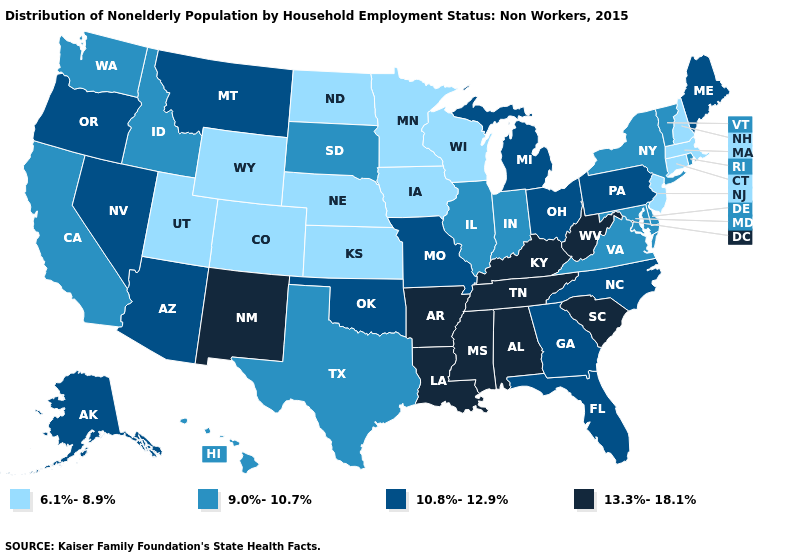Which states have the lowest value in the USA?
Give a very brief answer. Colorado, Connecticut, Iowa, Kansas, Massachusetts, Minnesota, Nebraska, New Hampshire, New Jersey, North Dakota, Utah, Wisconsin, Wyoming. Name the states that have a value in the range 6.1%-8.9%?
Answer briefly. Colorado, Connecticut, Iowa, Kansas, Massachusetts, Minnesota, Nebraska, New Hampshire, New Jersey, North Dakota, Utah, Wisconsin, Wyoming. Does Massachusetts have the same value as Wisconsin?
Concise answer only. Yes. Name the states that have a value in the range 6.1%-8.9%?
Answer briefly. Colorado, Connecticut, Iowa, Kansas, Massachusetts, Minnesota, Nebraska, New Hampshire, New Jersey, North Dakota, Utah, Wisconsin, Wyoming. Which states hav the highest value in the MidWest?
Be succinct. Michigan, Missouri, Ohio. Which states have the lowest value in the MidWest?
Write a very short answer. Iowa, Kansas, Minnesota, Nebraska, North Dakota, Wisconsin. Does South Dakota have a lower value than Alaska?
Short answer required. Yes. Name the states that have a value in the range 6.1%-8.9%?
Be succinct. Colorado, Connecticut, Iowa, Kansas, Massachusetts, Minnesota, Nebraska, New Hampshire, New Jersey, North Dakota, Utah, Wisconsin, Wyoming. Does Florida have a higher value than Maryland?
Quick response, please. Yes. Name the states that have a value in the range 10.8%-12.9%?
Short answer required. Alaska, Arizona, Florida, Georgia, Maine, Michigan, Missouri, Montana, Nevada, North Carolina, Ohio, Oklahoma, Oregon, Pennsylvania. Among the states that border Utah , does Colorado have the lowest value?
Write a very short answer. Yes. Which states have the highest value in the USA?
Be succinct. Alabama, Arkansas, Kentucky, Louisiana, Mississippi, New Mexico, South Carolina, Tennessee, West Virginia. Does Vermont have a higher value than North Carolina?
Write a very short answer. No. What is the value of North Dakota?
Keep it brief. 6.1%-8.9%. What is the highest value in states that border New Mexico?
Answer briefly. 10.8%-12.9%. 